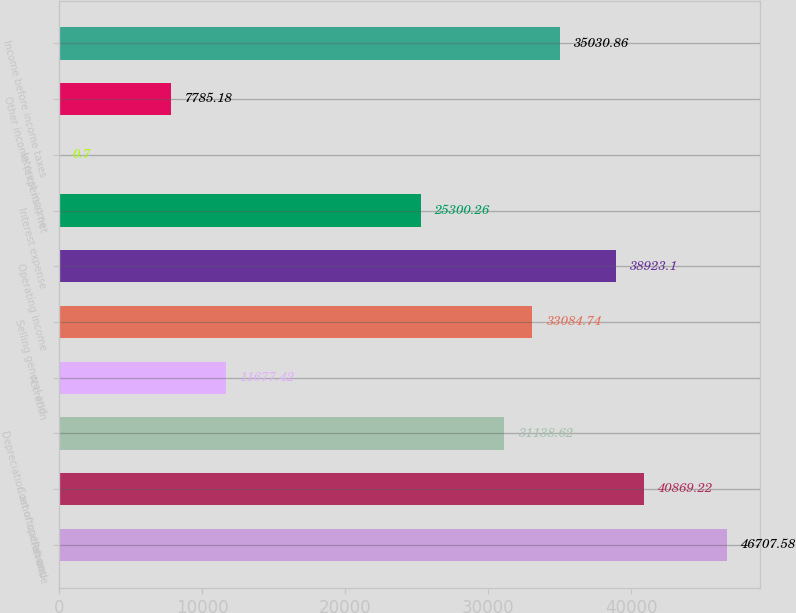<chart> <loc_0><loc_0><loc_500><loc_500><bar_chart><fcel>Revenue<fcel>Cost of operations<fcel>Depreciation amortization and<fcel>Accretion<fcel>Selling general and<fcel>Operating income<fcel>Interest expense<fcel>Interest income<fcel>Other income (expense) net<fcel>Income before income taxes<nl><fcel>46707.6<fcel>40869.2<fcel>31138.6<fcel>11677.4<fcel>33084.7<fcel>38923.1<fcel>25300.3<fcel>0.7<fcel>7785.18<fcel>35030.9<nl></chart> 